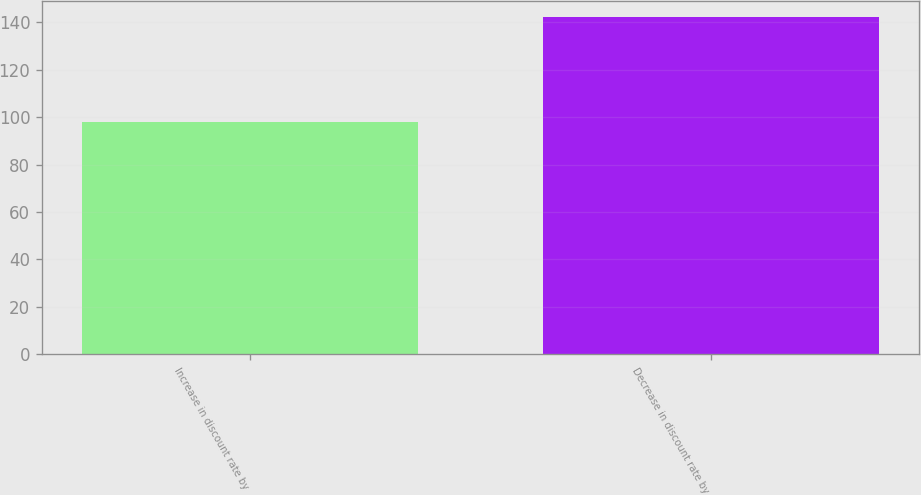Convert chart to OTSL. <chart><loc_0><loc_0><loc_500><loc_500><bar_chart><fcel>Increase in discount rate by<fcel>Decrease in discount rate by<nl><fcel>98<fcel>142<nl></chart> 